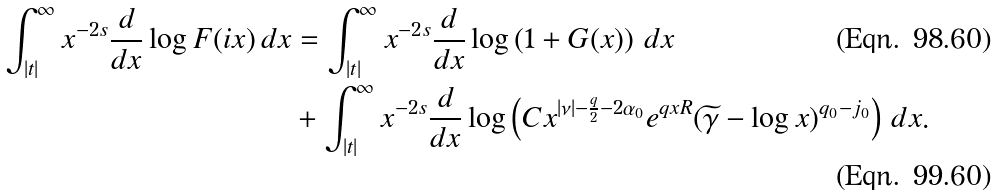<formula> <loc_0><loc_0><loc_500><loc_500>\int _ { | t | } ^ { \infty } x ^ { - 2 s } \frac { d } { d x } \log F ( i x ) \, d x & = \int _ { | t | } ^ { \infty } x ^ { - 2 s } \frac { d } { d x } \log \left ( 1 + G ( x ) \right ) \, d x \\ & + \int _ { | t | } ^ { \infty } x ^ { - 2 s } \frac { d } { d x } \log \left ( C x ^ { | \nu | - \frac { q } { 2 } - 2 \alpha _ { 0 } } e ^ { q x R } ( \widetilde { \gamma } - \log x ) ^ { q _ { 0 } - j _ { 0 } } \right ) \, d x .</formula> 